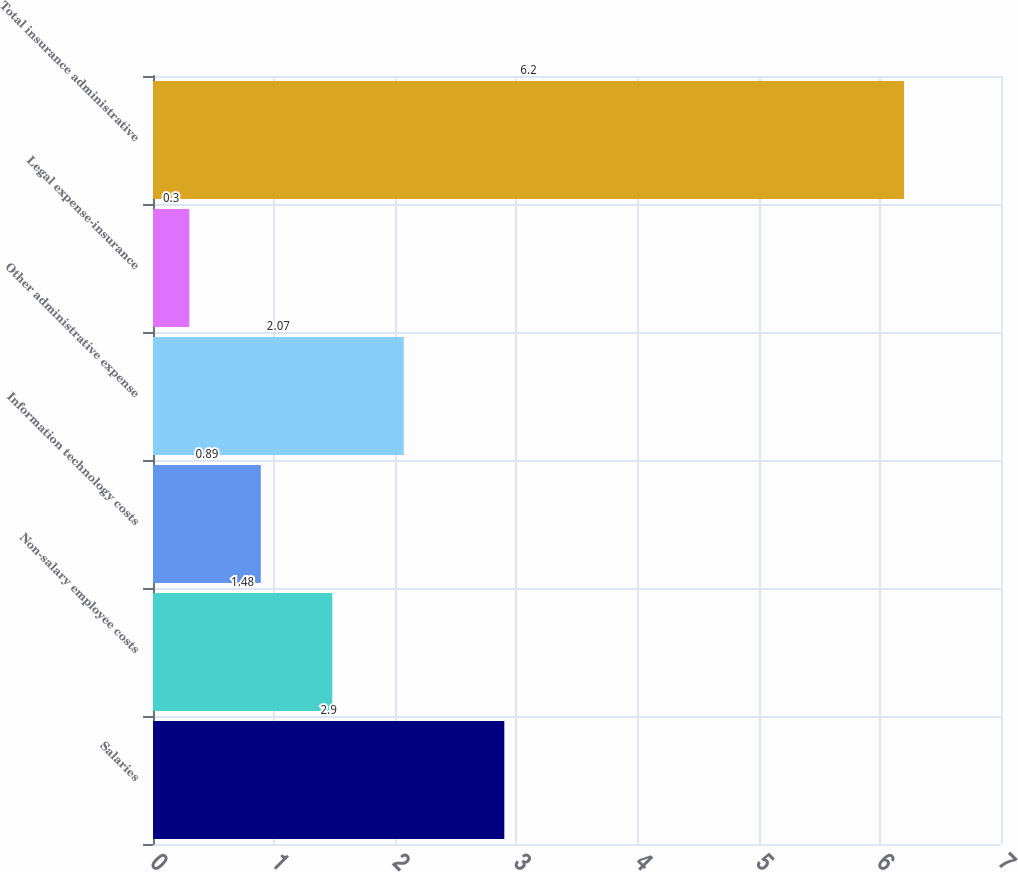Convert chart. <chart><loc_0><loc_0><loc_500><loc_500><bar_chart><fcel>Salaries<fcel>Non-salary employee costs<fcel>Information technology costs<fcel>Other administrative expense<fcel>Legal expense-insurance<fcel>Total insurance administrative<nl><fcel>2.9<fcel>1.48<fcel>0.89<fcel>2.07<fcel>0.3<fcel>6.2<nl></chart> 